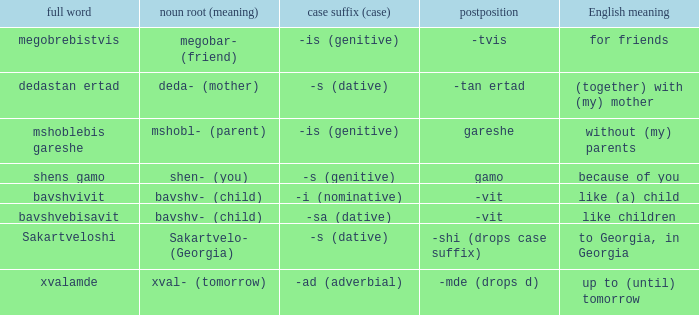What is English Meaning, when Full Word is "Shens Gamo"? Because of you. 